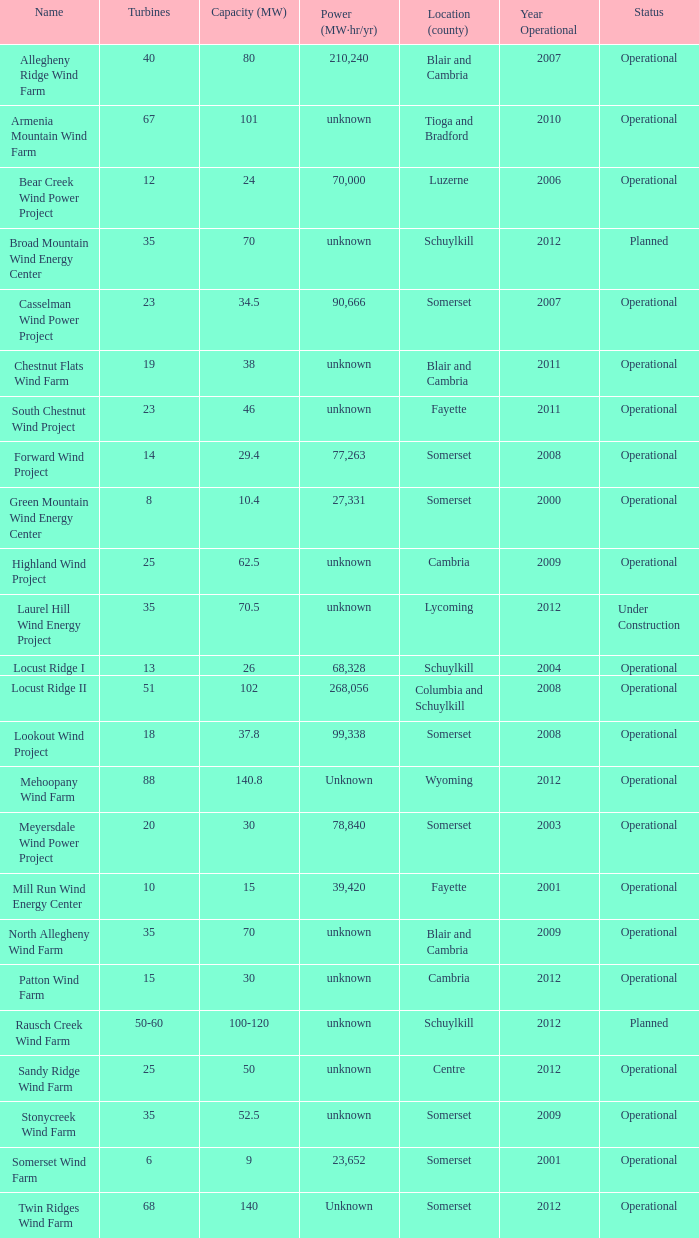Between 50 and 60, what are the different turbine capacities? 100-120. 